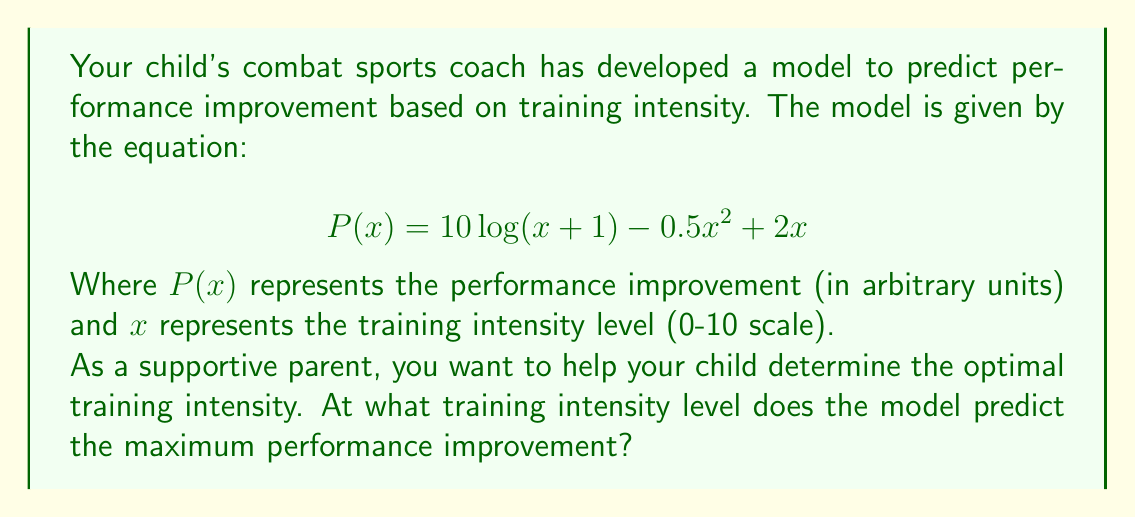Give your solution to this math problem. To find the maximum performance improvement, we need to find the value of $x$ where the derivative of $P(x)$ equals zero.

1) First, let's find the derivative of $P(x)$:

   $$P'(x) = \frac{d}{dx}[10\log(x+1) - 0.5x^2 + 2x]$$
   $$P'(x) = \frac{10}{x+1} - x + 2$$

2) Now, set the derivative equal to zero:

   $$\frac{10}{x+1} - x + 2 = 0$$

3) Multiply both sides by $(x+1)$:

   $$10 - x(x+1) + 2(x+1) = 0$$
   $$10 - x^2 - x + 2x + 2 = 0$$
   $$12 - x^2 + x = 0$$

4) Rearrange into standard quadratic form:

   $$x^2 - x - 12 = 0$$

5) Use the quadratic formula to solve for $x$:

   $$x = \frac{-b \pm \sqrt{b^2 - 4ac}}{2a}$$
   
   Where $a=1$, $b=-1$, and $c=-12$

   $$x = \frac{1 \pm \sqrt{1 - 4(1)(-12)}}{2(1)}$$
   $$x = \frac{1 \pm \sqrt{49}}{2}$$
   $$x = \frac{1 \pm 7}{2}$$

6) This gives us two solutions: $x = 4$ or $x = -3$

7) Since training intensity can't be negative, we discard the negative solution.

Therefore, the model predicts maximum performance improvement at a training intensity level of 4.
Answer: 4 